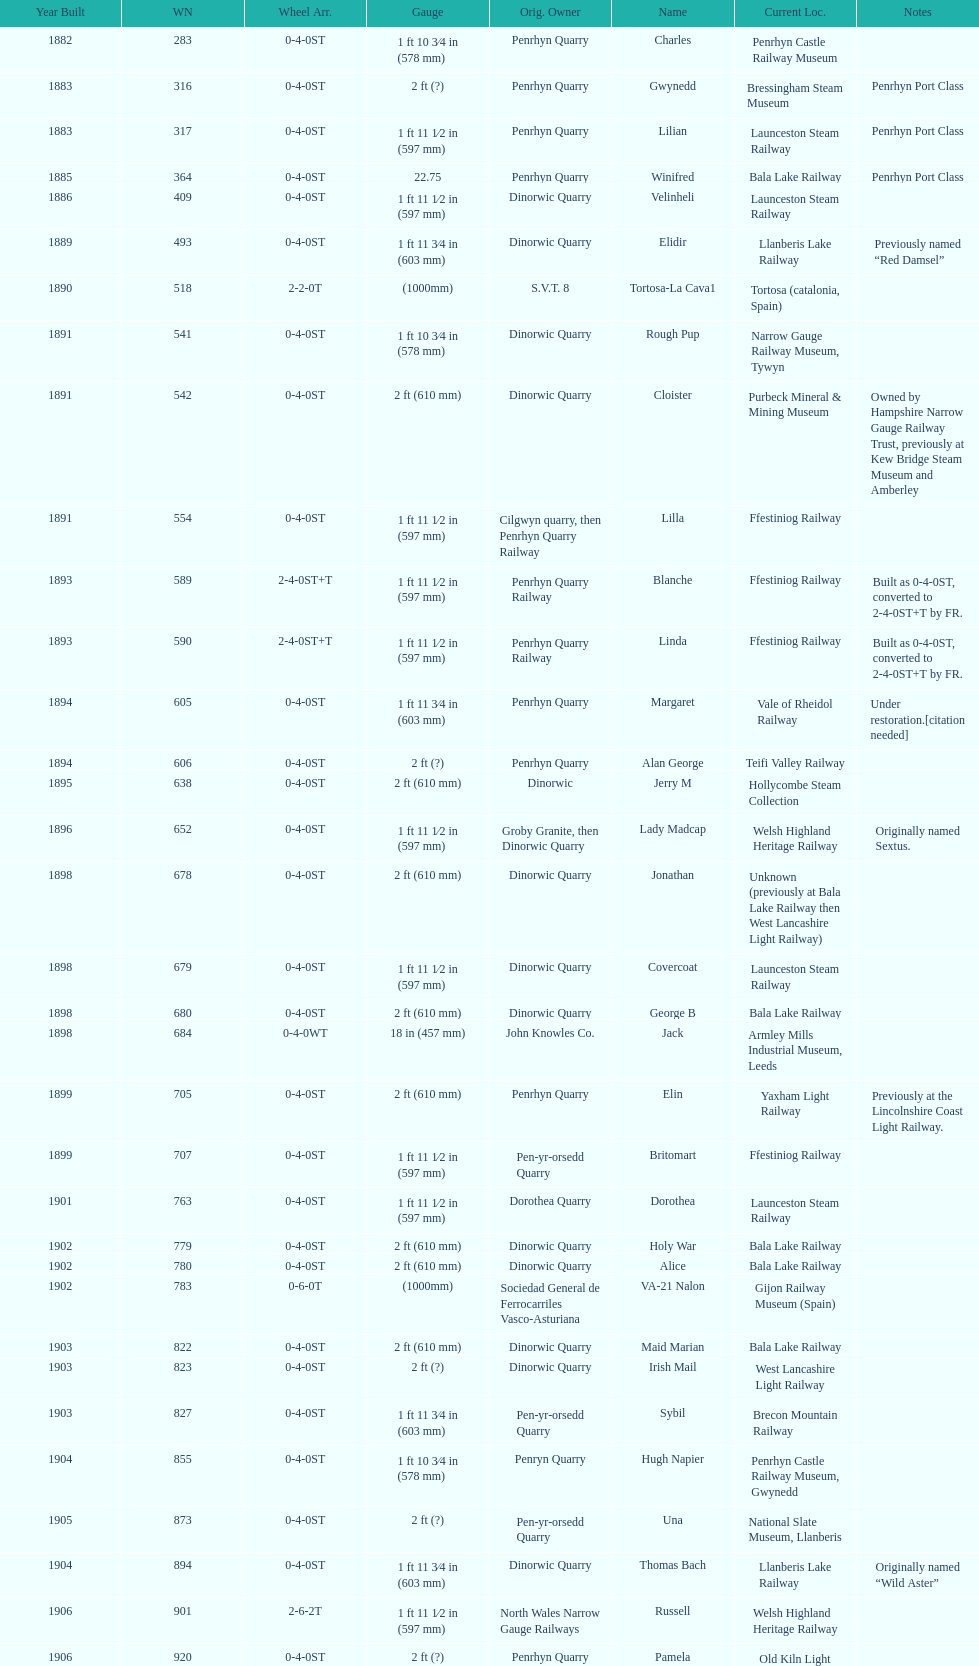Which works number had a larger gauge, 283 or 317? 317. 